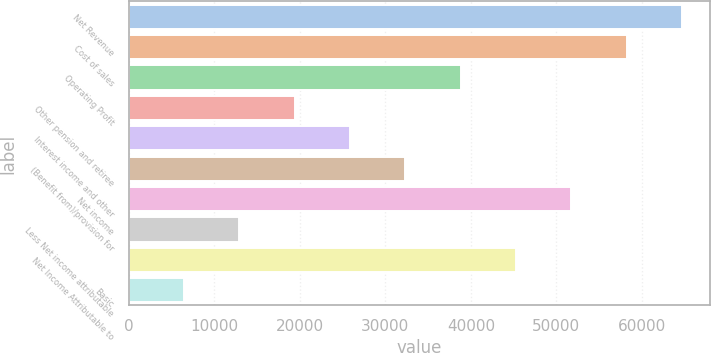Convert chart. <chart><loc_0><loc_0><loc_500><loc_500><bar_chart><fcel>Net Revenue<fcel>Cost of sales<fcel>Operating Profit<fcel>Other pension and retiree<fcel>Interest income and other<fcel>(Benefit from)/provision for<fcel>Net income<fcel>Less Net income attributable<fcel>Net Income Attributable to<fcel>Basic<nl><fcel>64661<fcel>58195.8<fcel>38800.1<fcel>19404.4<fcel>25869.7<fcel>32334.9<fcel>51730.5<fcel>12939.2<fcel>45265.3<fcel>6474<nl></chart> 